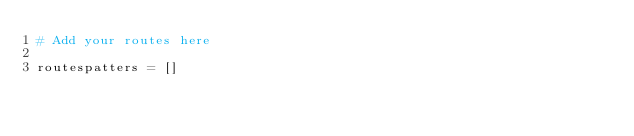Convert code to text. <code><loc_0><loc_0><loc_500><loc_500><_Python_># Add your routes here

routespatters = []
</code> 